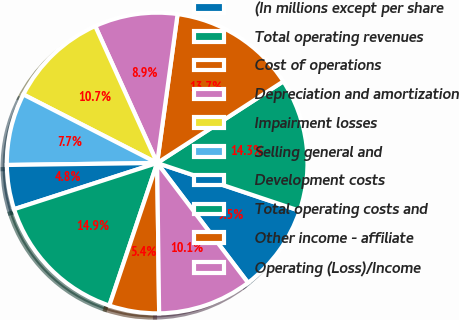Convert chart. <chart><loc_0><loc_0><loc_500><loc_500><pie_chart><fcel>(In millions except per share<fcel>Total operating revenues<fcel>Cost of operations<fcel>Depreciation and amortization<fcel>Impairment losses<fcel>Selling general and<fcel>Development costs<fcel>Total operating costs and<fcel>Other income - affiliate<fcel>Operating (Loss)/Income<nl><fcel>9.52%<fcel>14.29%<fcel>13.69%<fcel>8.93%<fcel>10.71%<fcel>7.74%<fcel>4.76%<fcel>14.88%<fcel>5.36%<fcel>10.12%<nl></chart> 